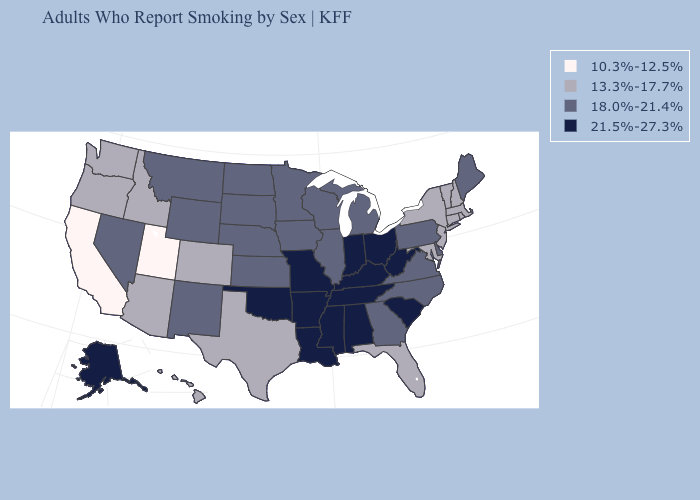Among the states that border Vermont , which have the lowest value?
Be succinct. Massachusetts, New Hampshire, New York. What is the lowest value in states that border Idaho?
Give a very brief answer. 10.3%-12.5%. Does the map have missing data?
Answer briefly. No. Among the states that border Missouri , which have the highest value?
Write a very short answer. Arkansas, Kentucky, Oklahoma, Tennessee. What is the highest value in the USA?
Give a very brief answer. 21.5%-27.3%. Does the first symbol in the legend represent the smallest category?
Keep it brief. Yes. Among the states that border North Carolina , which have the highest value?
Keep it brief. South Carolina, Tennessee. Name the states that have a value in the range 21.5%-27.3%?
Short answer required. Alabama, Alaska, Arkansas, Indiana, Kentucky, Louisiana, Mississippi, Missouri, Ohio, Oklahoma, South Carolina, Tennessee, West Virginia. What is the highest value in the USA?
Keep it brief. 21.5%-27.3%. Is the legend a continuous bar?
Short answer required. No. What is the value of Florida?
Concise answer only. 13.3%-17.7%. Does Mississippi have the highest value in the South?
Answer briefly. Yes. What is the value of Nevada?
Keep it brief. 18.0%-21.4%. What is the value of Delaware?
Answer briefly. 18.0%-21.4%. Name the states that have a value in the range 21.5%-27.3%?
Short answer required. Alabama, Alaska, Arkansas, Indiana, Kentucky, Louisiana, Mississippi, Missouri, Ohio, Oklahoma, South Carolina, Tennessee, West Virginia. 